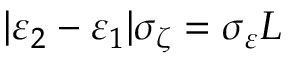<formula> <loc_0><loc_0><loc_500><loc_500>| \varepsilon _ { 2 } - \varepsilon _ { 1 } | \sigma _ { \zeta } = \sigma _ { \varepsilon } L</formula> 